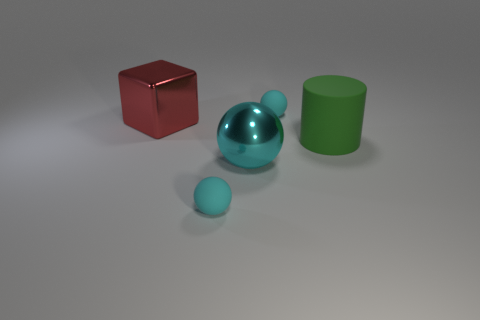What material is the red block?
Your answer should be very brief. Metal. How many tiny cyan matte objects are behind the tiny object in front of the big green matte cylinder?
Ensure brevity in your answer.  1. Is the color of the big cube the same as the rubber sphere that is behind the green cylinder?
Your response must be concise. No. There is a matte cylinder that is the same size as the metallic cube; what color is it?
Offer a terse response. Green. Is there a brown thing that has the same shape as the large cyan metal object?
Give a very brief answer. No. Are there fewer spheres than cyan rubber objects?
Ensure brevity in your answer.  No. There is a large object behind the large green matte cylinder; what is its color?
Ensure brevity in your answer.  Red. There is a small cyan matte thing right of the matte thing in front of the green cylinder; what shape is it?
Offer a terse response. Sphere. Are the large green thing and the cyan ball that is in front of the big cyan metallic thing made of the same material?
Give a very brief answer. Yes. How many cylinders are the same size as the red block?
Offer a terse response. 1. 